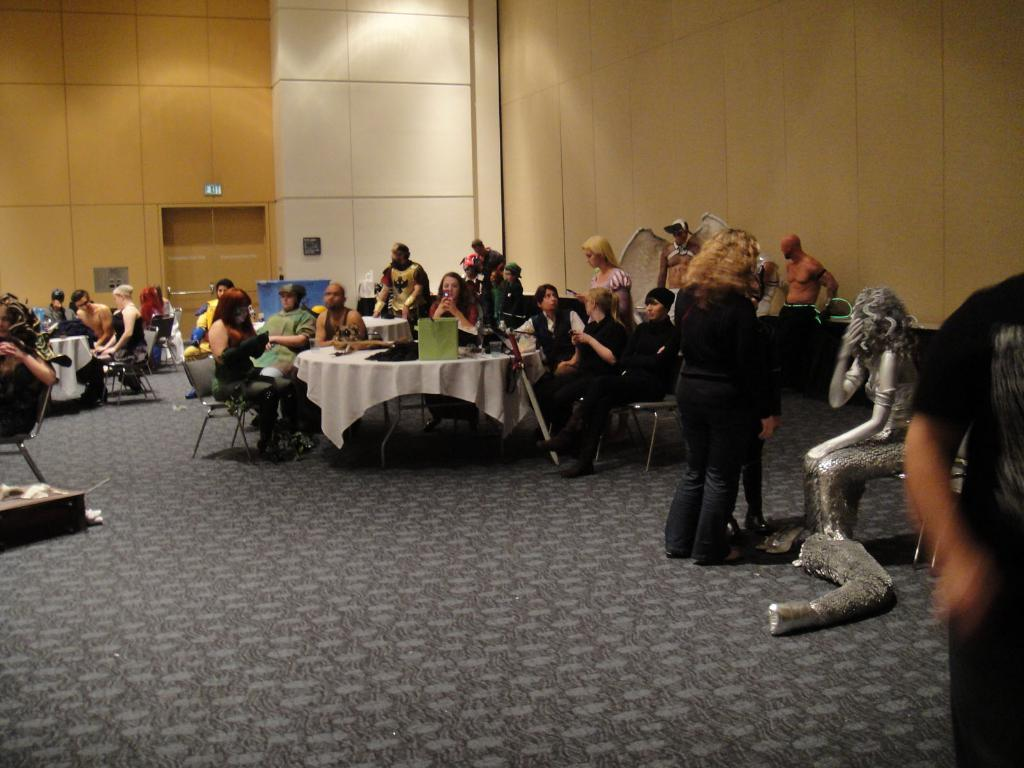How many people are in the image? There are people in the image, but the exact number is not specified. What are some of the people doing in the image? Some people are standing, and some people are sitting on chairs. What furniture is present in the image? There are tables in the image. Reasoning: Let's think step by following the guidelines to produce the conversation. We start by acknowledging the presence of people in the image, but we avoid specifying an exact number since it is not mentioned in the facts. Then, we describe the actions of some people, such as standing and sitting on chairs. Finally, we mention the presence of tables in the image. Absurd Question/Answer: What type of destruction can be seen in the image? There is no destruction present in the image. Is there a fight happening in the image? There is no fight depicted in the image. 